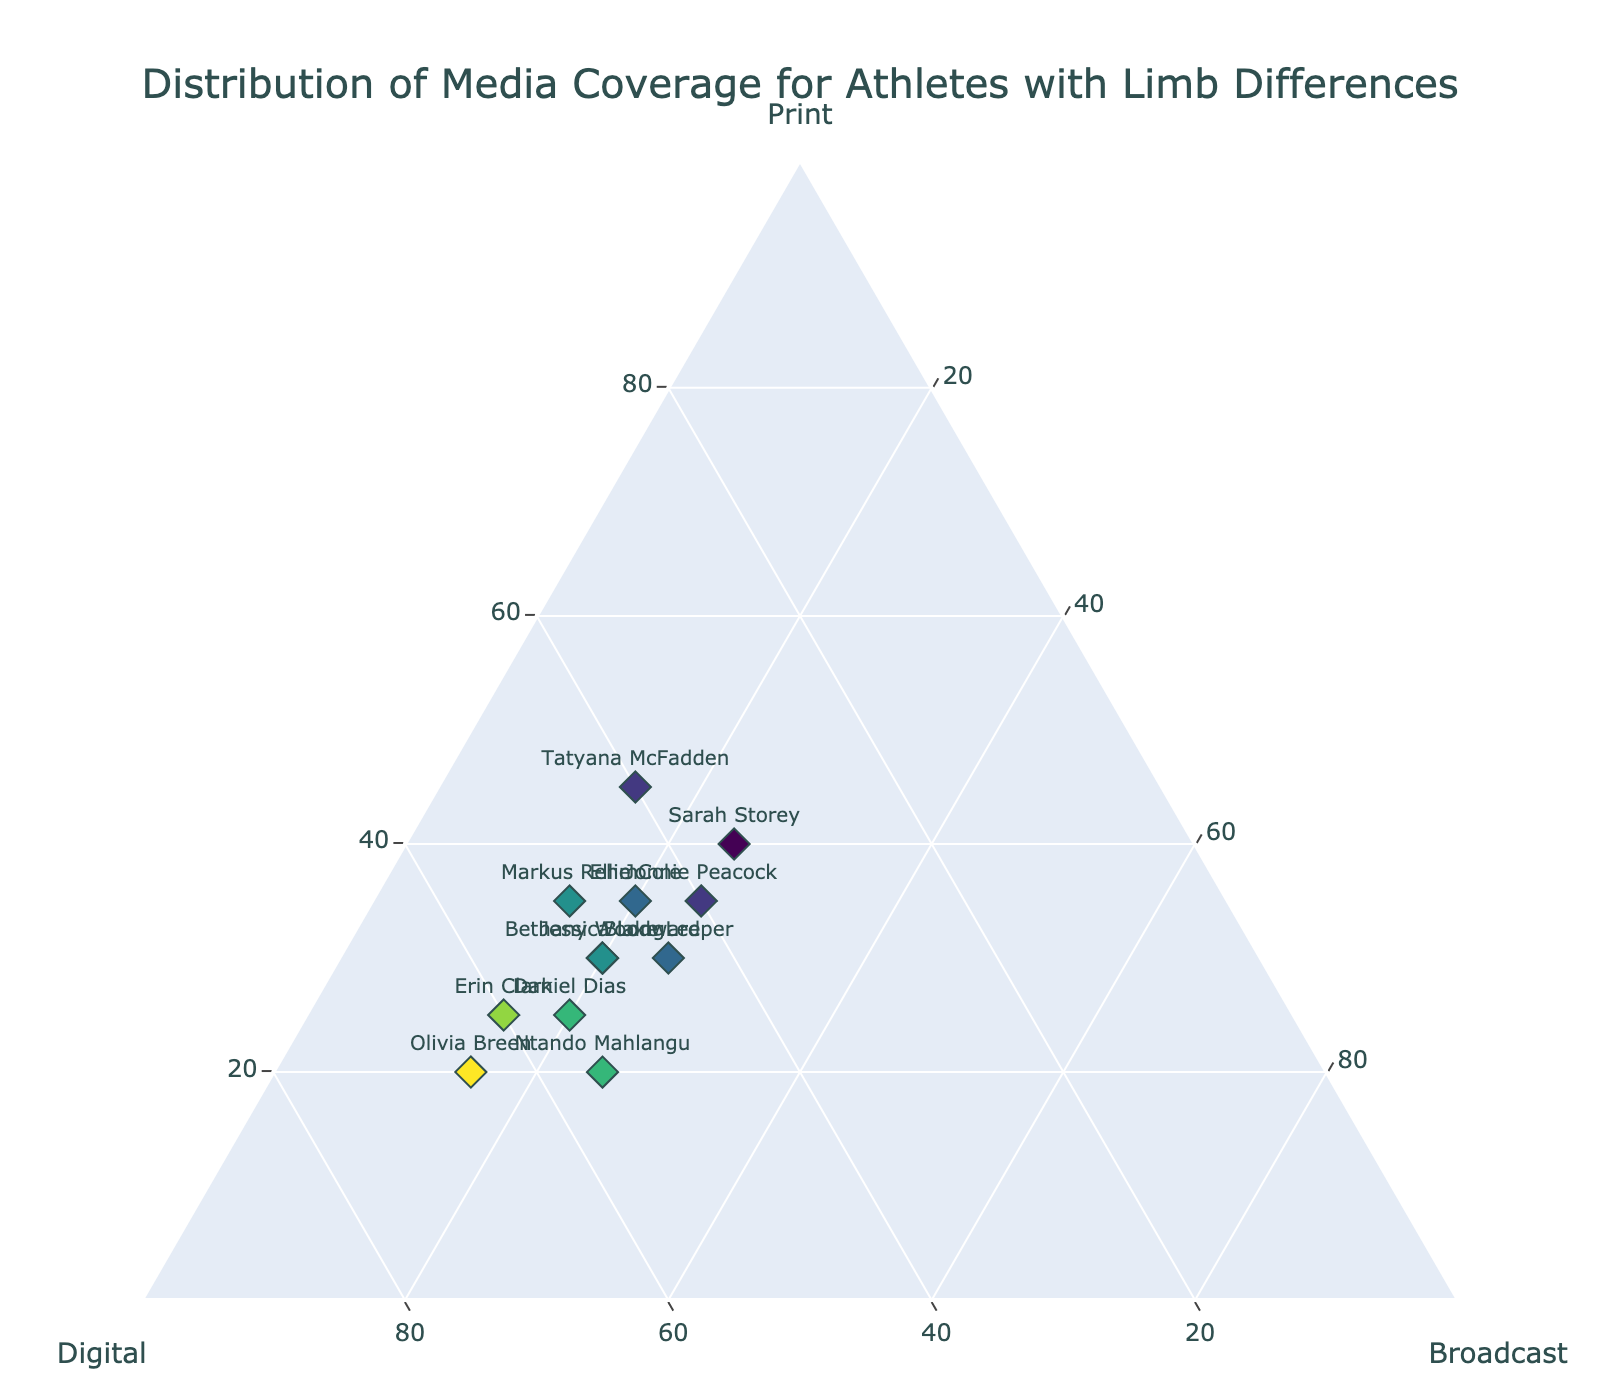How many athletes are shown in the plot? Count the number of unique data points (athletes) in the plot, which are represented by markers.
Answer: 12 What is the title of the plot? The title is usually displayed at the top of the plot and is clearly stated.
Answer: Distribution of Media Coverage for Athletes with Limb Differences Which athlete received the highest proportion of print coverage? Locate the athlete whose marker is positioned closest to the 'Print' axis peak on the ternary plot.
Answer: Tatyana McFadden What is the average amount of digital coverage for the athletes? Sum the digital coverage values for all athletes and divide by the number of athletes: (50+60+40+55+45+35+50+40+55+50+65+45)/12
Answer: 49.58 Are there any athletes with equal broadcast and print coverage? Compare the 'Broadcast' and 'Print' percentages for each athlete to identify any matches.
Answer: No Who received the least proportion of broadcast coverage? Identify the athlete whose marker is positioned closest to the base of the 'Broadcast' axis.
Answer: Erin Clark Which athletes received higher digital coverage than print coverage? Compare the 'Digital' and 'Print' coverage for each athlete to see who has a higher value in digital.
Answer: Bethany Woodward, Erin Clark, Ntando Mahlangu, Daniel Dias, Olivia Breen How does Sarah Storey's media coverage distribution compare to Jonnie Peacock's? Check the position of markers for Sarah Storey and Jonnie Peacock and compare their 'Print', 'Digital', and 'Broadcast' values. Sarah Storey has higher 'Print' and lower 'Digital' compared to Jonnie Peacock, but both have the same 'Broadcast'.
Answer: Sarah Storey has higher print and lower digital Which two athletes have the same broadcast coverage but different total digital and print coverage? Identify pairs of athletes with the same broadcast values and then compare their 'Print' and 'Digital' values.
Answer: Jonnie Peacock and Blake Leeper 